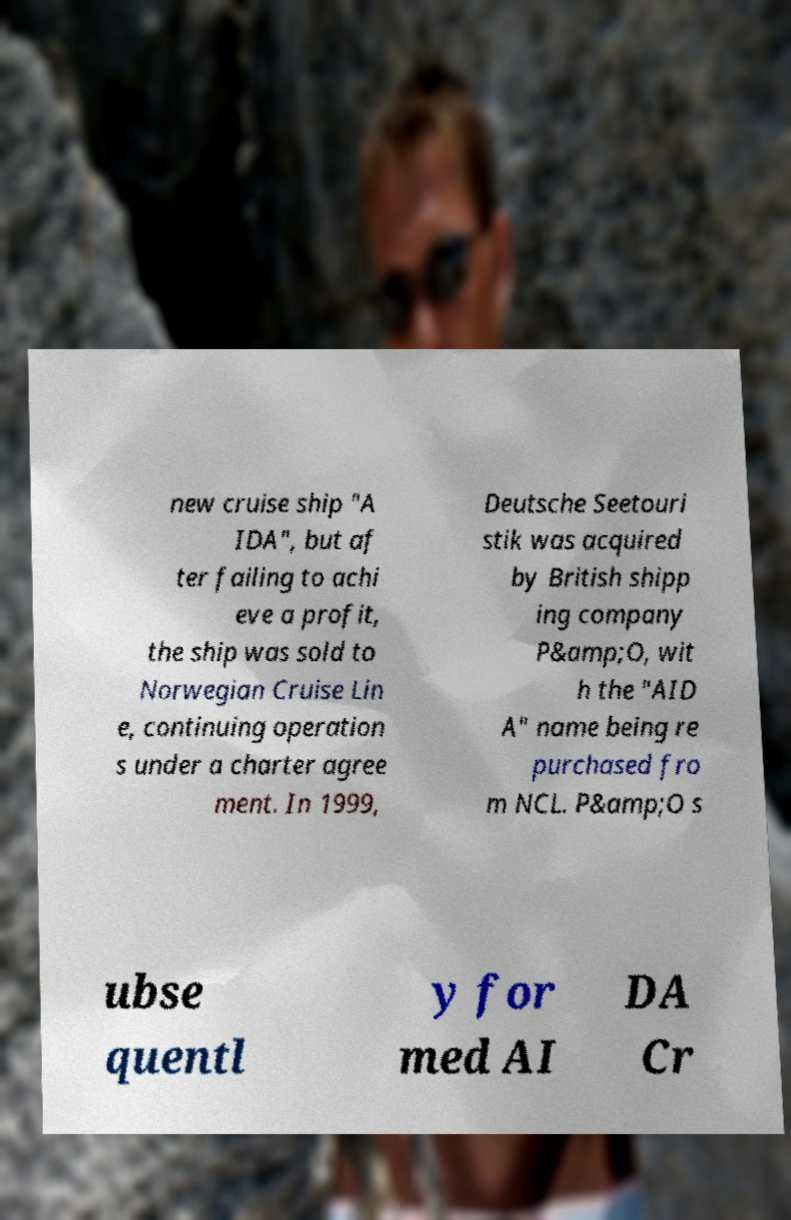Can you accurately transcribe the text from the provided image for me? new cruise ship "A IDA", but af ter failing to achi eve a profit, the ship was sold to Norwegian Cruise Lin e, continuing operation s under a charter agree ment. In 1999, Deutsche Seetouri stik was acquired by British shipp ing company P&amp;O, wit h the "AID A" name being re purchased fro m NCL. P&amp;O s ubse quentl y for med AI DA Cr 